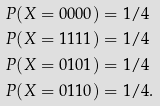Convert formula to latex. <formula><loc_0><loc_0><loc_500><loc_500>P ( X = 0 0 0 0 ) & = 1 / 4 \\ P ( X = 1 1 1 1 ) & = 1 / 4 \\ P ( X = 0 1 0 1 ) & = 1 / 4 \\ P ( X = 0 1 1 0 ) & = 1 / 4 .</formula> 